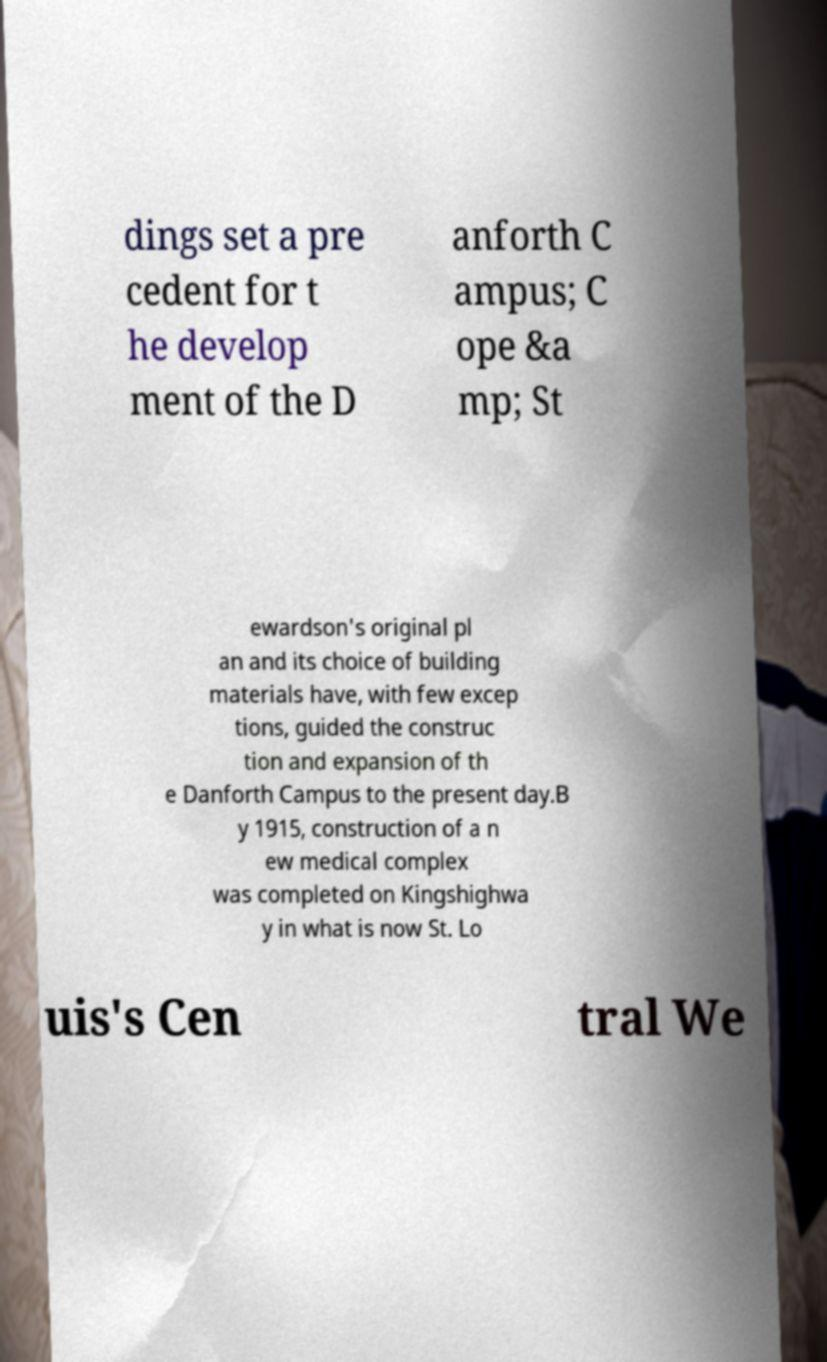Could you extract and type out the text from this image? dings set a pre cedent for t he develop ment of the D anforth C ampus; C ope &a mp; St ewardson's original pl an and its choice of building materials have, with few excep tions, guided the construc tion and expansion of th e Danforth Campus to the present day.B y 1915, construction of a n ew medical complex was completed on Kingshighwa y in what is now St. Lo uis's Cen tral We 